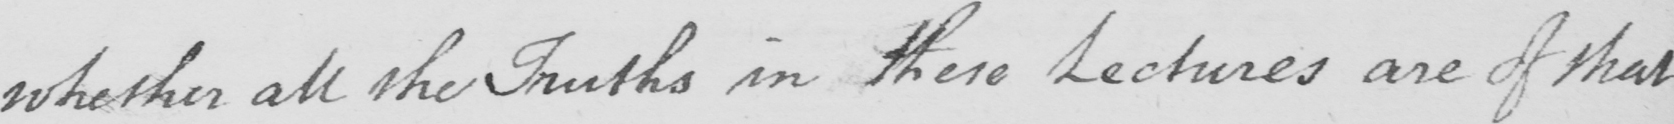Please provide the text content of this handwritten line. whether all the Truths in these Lectures are of that 